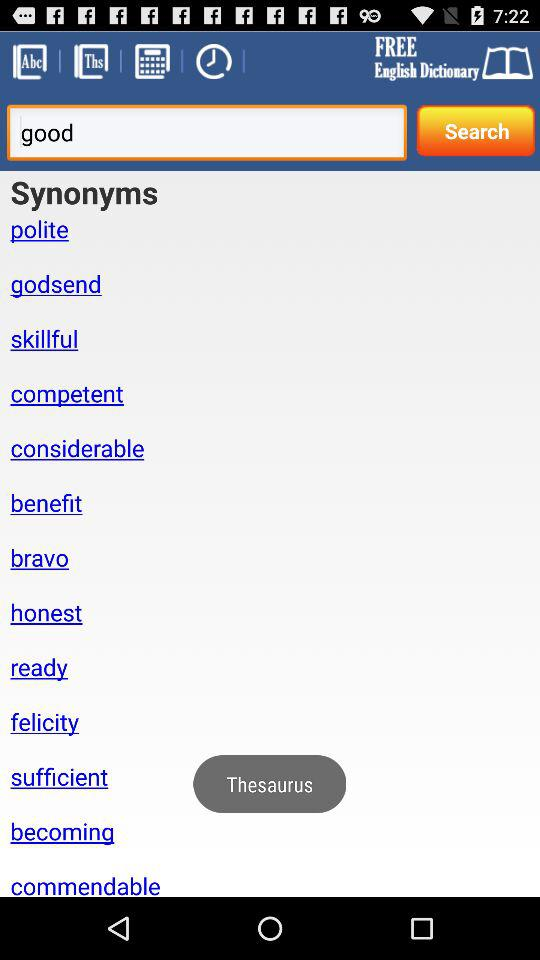What is the input text entered in the search bar? The input text entered is "good". 